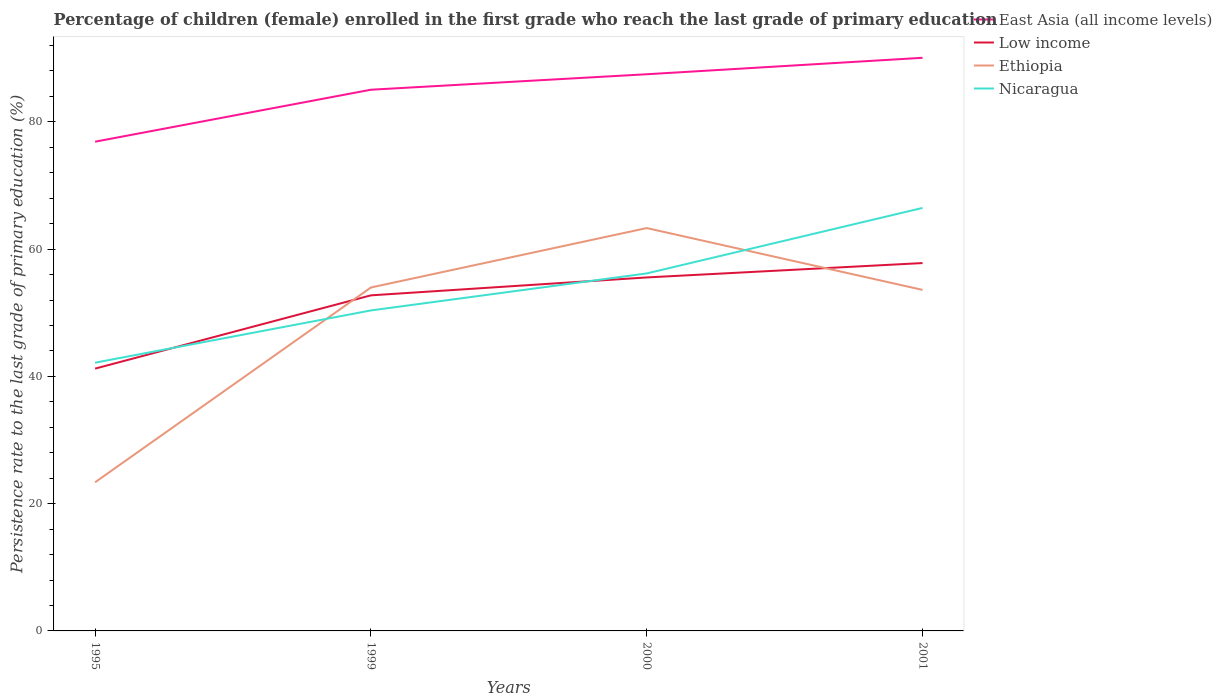How many different coloured lines are there?
Your response must be concise. 4. Is the number of lines equal to the number of legend labels?
Make the answer very short. Yes. Across all years, what is the maximum persistence rate of children in East Asia (all income levels)?
Offer a terse response. 76.89. What is the total persistence rate of children in Nicaragua in the graph?
Make the answer very short. -24.32. What is the difference between the highest and the second highest persistence rate of children in Nicaragua?
Give a very brief answer. 24.32. What is the difference between the highest and the lowest persistence rate of children in Ethiopia?
Make the answer very short. 3. Is the persistence rate of children in Nicaragua strictly greater than the persistence rate of children in East Asia (all income levels) over the years?
Your response must be concise. Yes. Are the values on the major ticks of Y-axis written in scientific E-notation?
Provide a succinct answer. No. Does the graph contain grids?
Your answer should be very brief. No. Where does the legend appear in the graph?
Make the answer very short. Top right. How many legend labels are there?
Provide a succinct answer. 4. How are the legend labels stacked?
Provide a short and direct response. Vertical. What is the title of the graph?
Offer a terse response. Percentage of children (female) enrolled in the first grade who reach the last grade of primary education. What is the label or title of the Y-axis?
Keep it short and to the point. Persistence rate to the last grade of primary education (%). What is the Persistence rate to the last grade of primary education (%) of East Asia (all income levels) in 1995?
Provide a short and direct response. 76.89. What is the Persistence rate to the last grade of primary education (%) in Low income in 1995?
Keep it short and to the point. 41.22. What is the Persistence rate to the last grade of primary education (%) of Ethiopia in 1995?
Offer a very short reply. 23.36. What is the Persistence rate to the last grade of primary education (%) of Nicaragua in 1995?
Offer a terse response. 42.16. What is the Persistence rate to the last grade of primary education (%) in East Asia (all income levels) in 1999?
Your answer should be very brief. 85.05. What is the Persistence rate to the last grade of primary education (%) in Low income in 1999?
Make the answer very short. 52.74. What is the Persistence rate to the last grade of primary education (%) in Ethiopia in 1999?
Ensure brevity in your answer.  53.97. What is the Persistence rate to the last grade of primary education (%) of Nicaragua in 1999?
Ensure brevity in your answer.  50.37. What is the Persistence rate to the last grade of primary education (%) of East Asia (all income levels) in 2000?
Provide a succinct answer. 87.48. What is the Persistence rate to the last grade of primary education (%) of Low income in 2000?
Your answer should be compact. 55.55. What is the Persistence rate to the last grade of primary education (%) of Ethiopia in 2000?
Give a very brief answer. 63.31. What is the Persistence rate to the last grade of primary education (%) in Nicaragua in 2000?
Give a very brief answer. 56.18. What is the Persistence rate to the last grade of primary education (%) of East Asia (all income levels) in 2001?
Provide a short and direct response. 90.07. What is the Persistence rate to the last grade of primary education (%) of Low income in 2001?
Offer a terse response. 57.81. What is the Persistence rate to the last grade of primary education (%) of Ethiopia in 2001?
Offer a terse response. 53.6. What is the Persistence rate to the last grade of primary education (%) in Nicaragua in 2001?
Keep it short and to the point. 66.48. Across all years, what is the maximum Persistence rate to the last grade of primary education (%) in East Asia (all income levels)?
Offer a terse response. 90.07. Across all years, what is the maximum Persistence rate to the last grade of primary education (%) of Low income?
Offer a very short reply. 57.81. Across all years, what is the maximum Persistence rate to the last grade of primary education (%) of Ethiopia?
Your answer should be compact. 63.31. Across all years, what is the maximum Persistence rate to the last grade of primary education (%) in Nicaragua?
Your response must be concise. 66.48. Across all years, what is the minimum Persistence rate to the last grade of primary education (%) in East Asia (all income levels)?
Your answer should be compact. 76.89. Across all years, what is the minimum Persistence rate to the last grade of primary education (%) of Low income?
Offer a very short reply. 41.22. Across all years, what is the minimum Persistence rate to the last grade of primary education (%) in Ethiopia?
Provide a succinct answer. 23.36. Across all years, what is the minimum Persistence rate to the last grade of primary education (%) in Nicaragua?
Give a very brief answer. 42.16. What is the total Persistence rate to the last grade of primary education (%) of East Asia (all income levels) in the graph?
Your answer should be compact. 339.49. What is the total Persistence rate to the last grade of primary education (%) in Low income in the graph?
Provide a short and direct response. 207.33. What is the total Persistence rate to the last grade of primary education (%) of Ethiopia in the graph?
Your answer should be very brief. 194.24. What is the total Persistence rate to the last grade of primary education (%) in Nicaragua in the graph?
Your answer should be compact. 215.18. What is the difference between the Persistence rate to the last grade of primary education (%) in East Asia (all income levels) in 1995 and that in 1999?
Make the answer very short. -8.17. What is the difference between the Persistence rate to the last grade of primary education (%) of Low income in 1995 and that in 1999?
Keep it short and to the point. -11.52. What is the difference between the Persistence rate to the last grade of primary education (%) of Ethiopia in 1995 and that in 1999?
Offer a very short reply. -30.61. What is the difference between the Persistence rate to the last grade of primary education (%) of Nicaragua in 1995 and that in 1999?
Your answer should be compact. -8.21. What is the difference between the Persistence rate to the last grade of primary education (%) of East Asia (all income levels) in 1995 and that in 2000?
Give a very brief answer. -10.6. What is the difference between the Persistence rate to the last grade of primary education (%) in Low income in 1995 and that in 2000?
Provide a short and direct response. -14.33. What is the difference between the Persistence rate to the last grade of primary education (%) of Ethiopia in 1995 and that in 2000?
Ensure brevity in your answer.  -39.95. What is the difference between the Persistence rate to the last grade of primary education (%) in Nicaragua in 1995 and that in 2000?
Your answer should be very brief. -14.03. What is the difference between the Persistence rate to the last grade of primary education (%) in East Asia (all income levels) in 1995 and that in 2001?
Keep it short and to the point. -13.18. What is the difference between the Persistence rate to the last grade of primary education (%) of Low income in 1995 and that in 2001?
Your answer should be compact. -16.59. What is the difference between the Persistence rate to the last grade of primary education (%) in Ethiopia in 1995 and that in 2001?
Give a very brief answer. -30.23. What is the difference between the Persistence rate to the last grade of primary education (%) of Nicaragua in 1995 and that in 2001?
Give a very brief answer. -24.32. What is the difference between the Persistence rate to the last grade of primary education (%) of East Asia (all income levels) in 1999 and that in 2000?
Make the answer very short. -2.43. What is the difference between the Persistence rate to the last grade of primary education (%) in Low income in 1999 and that in 2000?
Provide a succinct answer. -2.81. What is the difference between the Persistence rate to the last grade of primary education (%) of Ethiopia in 1999 and that in 2000?
Provide a short and direct response. -9.34. What is the difference between the Persistence rate to the last grade of primary education (%) of Nicaragua in 1999 and that in 2000?
Make the answer very short. -5.82. What is the difference between the Persistence rate to the last grade of primary education (%) of East Asia (all income levels) in 1999 and that in 2001?
Your answer should be compact. -5.02. What is the difference between the Persistence rate to the last grade of primary education (%) in Low income in 1999 and that in 2001?
Your answer should be compact. -5.07. What is the difference between the Persistence rate to the last grade of primary education (%) in Ethiopia in 1999 and that in 2001?
Your response must be concise. 0.38. What is the difference between the Persistence rate to the last grade of primary education (%) in Nicaragua in 1999 and that in 2001?
Make the answer very short. -16.11. What is the difference between the Persistence rate to the last grade of primary education (%) in East Asia (all income levels) in 2000 and that in 2001?
Provide a short and direct response. -2.59. What is the difference between the Persistence rate to the last grade of primary education (%) of Low income in 2000 and that in 2001?
Your answer should be compact. -2.26. What is the difference between the Persistence rate to the last grade of primary education (%) of Ethiopia in 2000 and that in 2001?
Your answer should be compact. 9.72. What is the difference between the Persistence rate to the last grade of primary education (%) of Nicaragua in 2000 and that in 2001?
Offer a very short reply. -10.29. What is the difference between the Persistence rate to the last grade of primary education (%) of East Asia (all income levels) in 1995 and the Persistence rate to the last grade of primary education (%) of Low income in 1999?
Your answer should be very brief. 24.15. What is the difference between the Persistence rate to the last grade of primary education (%) of East Asia (all income levels) in 1995 and the Persistence rate to the last grade of primary education (%) of Ethiopia in 1999?
Offer a very short reply. 22.91. What is the difference between the Persistence rate to the last grade of primary education (%) of East Asia (all income levels) in 1995 and the Persistence rate to the last grade of primary education (%) of Nicaragua in 1999?
Provide a succinct answer. 26.52. What is the difference between the Persistence rate to the last grade of primary education (%) of Low income in 1995 and the Persistence rate to the last grade of primary education (%) of Ethiopia in 1999?
Give a very brief answer. -12.75. What is the difference between the Persistence rate to the last grade of primary education (%) of Low income in 1995 and the Persistence rate to the last grade of primary education (%) of Nicaragua in 1999?
Give a very brief answer. -9.14. What is the difference between the Persistence rate to the last grade of primary education (%) in Ethiopia in 1995 and the Persistence rate to the last grade of primary education (%) in Nicaragua in 1999?
Offer a very short reply. -27.01. What is the difference between the Persistence rate to the last grade of primary education (%) in East Asia (all income levels) in 1995 and the Persistence rate to the last grade of primary education (%) in Low income in 2000?
Make the answer very short. 21.33. What is the difference between the Persistence rate to the last grade of primary education (%) in East Asia (all income levels) in 1995 and the Persistence rate to the last grade of primary education (%) in Ethiopia in 2000?
Offer a very short reply. 13.57. What is the difference between the Persistence rate to the last grade of primary education (%) of East Asia (all income levels) in 1995 and the Persistence rate to the last grade of primary education (%) of Nicaragua in 2000?
Provide a succinct answer. 20.7. What is the difference between the Persistence rate to the last grade of primary education (%) of Low income in 1995 and the Persistence rate to the last grade of primary education (%) of Ethiopia in 2000?
Offer a very short reply. -22.09. What is the difference between the Persistence rate to the last grade of primary education (%) in Low income in 1995 and the Persistence rate to the last grade of primary education (%) in Nicaragua in 2000?
Offer a very short reply. -14.96. What is the difference between the Persistence rate to the last grade of primary education (%) in Ethiopia in 1995 and the Persistence rate to the last grade of primary education (%) in Nicaragua in 2000?
Your response must be concise. -32.82. What is the difference between the Persistence rate to the last grade of primary education (%) of East Asia (all income levels) in 1995 and the Persistence rate to the last grade of primary education (%) of Low income in 2001?
Provide a short and direct response. 19.07. What is the difference between the Persistence rate to the last grade of primary education (%) of East Asia (all income levels) in 1995 and the Persistence rate to the last grade of primary education (%) of Ethiopia in 2001?
Your answer should be very brief. 23.29. What is the difference between the Persistence rate to the last grade of primary education (%) of East Asia (all income levels) in 1995 and the Persistence rate to the last grade of primary education (%) of Nicaragua in 2001?
Your answer should be very brief. 10.41. What is the difference between the Persistence rate to the last grade of primary education (%) in Low income in 1995 and the Persistence rate to the last grade of primary education (%) in Ethiopia in 2001?
Offer a very short reply. -12.37. What is the difference between the Persistence rate to the last grade of primary education (%) in Low income in 1995 and the Persistence rate to the last grade of primary education (%) in Nicaragua in 2001?
Your response must be concise. -25.25. What is the difference between the Persistence rate to the last grade of primary education (%) in Ethiopia in 1995 and the Persistence rate to the last grade of primary education (%) in Nicaragua in 2001?
Ensure brevity in your answer.  -43.12. What is the difference between the Persistence rate to the last grade of primary education (%) in East Asia (all income levels) in 1999 and the Persistence rate to the last grade of primary education (%) in Low income in 2000?
Your answer should be very brief. 29.5. What is the difference between the Persistence rate to the last grade of primary education (%) of East Asia (all income levels) in 1999 and the Persistence rate to the last grade of primary education (%) of Ethiopia in 2000?
Provide a succinct answer. 21.74. What is the difference between the Persistence rate to the last grade of primary education (%) in East Asia (all income levels) in 1999 and the Persistence rate to the last grade of primary education (%) in Nicaragua in 2000?
Your answer should be very brief. 28.87. What is the difference between the Persistence rate to the last grade of primary education (%) of Low income in 1999 and the Persistence rate to the last grade of primary education (%) of Ethiopia in 2000?
Ensure brevity in your answer.  -10.57. What is the difference between the Persistence rate to the last grade of primary education (%) of Low income in 1999 and the Persistence rate to the last grade of primary education (%) of Nicaragua in 2000?
Make the answer very short. -3.44. What is the difference between the Persistence rate to the last grade of primary education (%) of Ethiopia in 1999 and the Persistence rate to the last grade of primary education (%) of Nicaragua in 2000?
Your answer should be compact. -2.21. What is the difference between the Persistence rate to the last grade of primary education (%) of East Asia (all income levels) in 1999 and the Persistence rate to the last grade of primary education (%) of Low income in 2001?
Offer a very short reply. 27.24. What is the difference between the Persistence rate to the last grade of primary education (%) of East Asia (all income levels) in 1999 and the Persistence rate to the last grade of primary education (%) of Ethiopia in 2001?
Offer a terse response. 31.46. What is the difference between the Persistence rate to the last grade of primary education (%) in East Asia (all income levels) in 1999 and the Persistence rate to the last grade of primary education (%) in Nicaragua in 2001?
Offer a terse response. 18.58. What is the difference between the Persistence rate to the last grade of primary education (%) in Low income in 1999 and the Persistence rate to the last grade of primary education (%) in Ethiopia in 2001?
Provide a short and direct response. -0.86. What is the difference between the Persistence rate to the last grade of primary education (%) in Low income in 1999 and the Persistence rate to the last grade of primary education (%) in Nicaragua in 2001?
Offer a terse response. -13.74. What is the difference between the Persistence rate to the last grade of primary education (%) in Ethiopia in 1999 and the Persistence rate to the last grade of primary education (%) in Nicaragua in 2001?
Offer a very short reply. -12.5. What is the difference between the Persistence rate to the last grade of primary education (%) of East Asia (all income levels) in 2000 and the Persistence rate to the last grade of primary education (%) of Low income in 2001?
Offer a terse response. 29.67. What is the difference between the Persistence rate to the last grade of primary education (%) in East Asia (all income levels) in 2000 and the Persistence rate to the last grade of primary education (%) in Ethiopia in 2001?
Provide a short and direct response. 33.89. What is the difference between the Persistence rate to the last grade of primary education (%) in East Asia (all income levels) in 2000 and the Persistence rate to the last grade of primary education (%) in Nicaragua in 2001?
Your response must be concise. 21.01. What is the difference between the Persistence rate to the last grade of primary education (%) of Low income in 2000 and the Persistence rate to the last grade of primary education (%) of Ethiopia in 2001?
Your answer should be very brief. 1.96. What is the difference between the Persistence rate to the last grade of primary education (%) of Low income in 2000 and the Persistence rate to the last grade of primary education (%) of Nicaragua in 2001?
Offer a very short reply. -10.92. What is the difference between the Persistence rate to the last grade of primary education (%) in Ethiopia in 2000 and the Persistence rate to the last grade of primary education (%) in Nicaragua in 2001?
Provide a succinct answer. -3.17. What is the average Persistence rate to the last grade of primary education (%) of East Asia (all income levels) per year?
Provide a succinct answer. 84.87. What is the average Persistence rate to the last grade of primary education (%) in Low income per year?
Provide a short and direct response. 51.83. What is the average Persistence rate to the last grade of primary education (%) of Ethiopia per year?
Offer a terse response. 48.56. What is the average Persistence rate to the last grade of primary education (%) in Nicaragua per year?
Keep it short and to the point. 53.8. In the year 1995, what is the difference between the Persistence rate to the last grade of primary education (%) in East Asia (all income levels) and Persistence rate to the last grade of primary education (%) in Low income?
Keep it short and to the point. 35.66. In the year 1995, what is the difference between the Persistence rate to the last grade of primary education (%) in East Asia (all income levels) and Persistence rate to the last grade of primary education (%) in Ethiopia?
Provide a short and direct response. 53.53. In the year 1995, what is the difference between the Persistence rate to the last grade of primary education (%) of East Asia (all income levels) and Persistence rate to the last grade of primary education (%) of Nicaragua?
Provide a short and direct response. 34.73. In the year 1995, what is the difference between the Persistence rate to the last grade of primary education (%) of Low income and Persistence rate to the last grade of primary education (%) of Ethiopia?
Offer a terse response. 17.86. In the year 1995, what is the difference between the Persistence rate to the last grade of primary education (%) in Low income and Persistence rate to the last grade of primary education (%) in Nicaragua?
Your response must be concise. -0.93. In the year 1995, what is the difference between the Persistence rate to the last grade of primary education (%) of Ethiopia and Persistence rate to the last grade of primary education (%) of Nicaragua?
Ensure brevity in your answer.  -18.8. In the year 1999, what is the difference between the Persistence rate to the last grade of primary education (%) of East Asia (all income levels) and Persistence rate to the last grade of primary education (%) of Low income?
Provide a succinct answer. 32.31. In the year 1999, what is the difference between the Persistence rate to the last grade of primary education (%) in East Asia (all income levels) and Persistence rate to the last grade of primary education (%) in Ethiopia?
Keep it short and to the point. 31.08. In the year 1999, what is the difference between the Persistence rate to the last grade of primary education (%) of East Asia (all income levels) and Persistence rate to the last grade of primary education (%) of Nicaragua?
Give a very brief answer. 34.69. In the year 1999, what is the difference between the Persistence rate to the last grade of primary education (%) of Low income and Persistence rate to the last grade of primary education (%) of Ethiopia?
Offer a terse response. -1.23. In the year 1999, what is the difference between the Persistence rate to the last grade of primary education (%) in Low income and Persistence rate to the last grade of primary education (%) in Nicaragua?
Your answer should be compact. 2.37. In the year 1999, what is the difference between the Persistence rate to the last grade of primary education (%) of Ethiopia and Persistence rate to the last grade of primary education (%) of Nicaragua?
Make the answer very short. 3.61. In the year 2000, what is the difference between the Persistence rate to the last grade of primary education (%) of East Asia (all income levels) and Persistence rate to the last grade of primary education (%) of Low income?
Make the answer very short. 31.93. In the year 2000, what is the difference between the Persistence rate to the last grade of primary education (%) in East Asia (all income levels) and Persistence rate to the last grade of primary education (%) in Ethiopia?
Provide a short and direct response. 24.17. In the year 2000, what is the difference between the Persistence rate to the last grade of primary education (%) in East Asia (all income levels) and Persistence rate to the last grade of primary education (%) in Nicaragua?
Ensure brevity in your answer.  31.3. In the year 2000, what is the difference between the Persistence rate to the last grade of primary education (%) of Low income and Persistence rate to the last grade of primary education (%) of Ethiopia?
Offer a terse response. -7.76. In the year 2000, what is the difference between the Persistence rate to the last grade of primary education (%) of Low income and Persistence rate to the last grade of primary education (%) of Nicaragua?
Provide a short and direct response. -0.63. In the year 2000, what is the difference between the Persistence rate to the last grade of primary education (%) of Ethiopia and Persistence rate to the last grade of primary education (%) of Nicaragua?
Provide a short and direct response. 7.13. In the year 2001, what is the difference between the Persistence rate to the last grade of primary education (%) of East Asia (all income levels) and Persistence rate to the last grade of primary education (%) of Low income?
Provide a short and direct response. 32.26. In the year 2001, what is the difference between the Persistence rate to the last grade of primary education (%) of East Asia (all income levels) and Persistence rate to the last grade of primary education (%) of Ethiopia?
Your answer should be compact. 36.48. In the year 2001, what is the difference between the Persistence rate to the last grade of primary education (%) in East Asia (all income levels) and Persistence rate to the last grade of primary education (%) in Nicaragua?
Offer a terse response. 23.59. In the year 2001, what is the difference between the Persistence rate to the last grade of primary education (%) of Low income and Persistence rate to the last grade of primary education (%) of Ethiopia?
Keep it short and to the point. 4.22. In the year 2001, what is the difference between the Persistence rate to the last grade of primary education (%) in Low income and Persistence rate to the last grade of primary education (%) in Nicaragua?
Keep it short and to the point. -8.67. In the year 2001, what is the difference between the Persistence rate to the last grade of primary education (%) in Ethiopia and Persistence rate to the last grade of primary education (%) in Nicaragua?
Your response must be concise. -12.88. What is the ratio of the Persistence rate to the last grade of primary education (%) in East Asia (all income levels) in 1995 to that in 1999?
Make the answer very short. 0.9. What is the ratio of the Persistence rate to the last grade of primary education (%) in Low income in 1995 to that in 1999?
Offer a very short reply. 0.78. What is the ratio of the Persistence rate to the last grade of primary education (%) of Ethiopia in 1995 to that in 1999?
Offer a very short reply. 0.43. What is the ratio of the Persistence rate to the last grade of primary education (%) in Nicaragua in 1995 to that in 1999?
Provide a short and direct response. 0.84. What is the ratio of the Persistence rate to the last grade of primary education (%) in East Asia (all income levels) in 1995 to that in 2000?
Provide a short and direct response. 0.88. What is the ratio of the Persistence rate to the last grade of primary education (%) in Low income in 1995 to that in 2000?
Your answer should be very brief. 0.74. What is the ratio of the Persistence rate to the last grade of primary education (%) of Ethiopia in 1995 to that in 2000?
Ensure brevity in your answer.  0.37. What is the ratio of the Persistence rate to the last grade of primary education (%) of Nicaragua in 1995 to that in 2000?
Your response must be concise. 0.75. What is the ratio of the Persistence rate to the last grade of primary education (%) of East Asia (all income levels) in 1995 to that in 2001?
Your answer should be very brief. 0.85. What is the ratio of the Persistence rate to the last grade of primary education (%) in Low income in 1995 to that in 2001?
Ensure brevity in your answer.  0.71. What is the ratio of the Persistence rate to the last grade of primary education (%) in Ethiopia in 1995 to that in 2001?
Your response must be concise. 0.44. What is the ratio of the Persistence rate to the last grade of primary education (%) in Nicaragua in 1995 to that in 2001?
Give a very brief answer. 0.63. What is the ratio of the Persistence rate to the last grade of primary education (%) of East Asia (all income levels) in 1999 to that in 2000?
Your response must be concise. 0.97. What is the ratio of the Persistence rate to the last grade of primary education (%) of Low income in 1999 to that in 2000?
Provide a succinct answer. 0.95. What is the ratio of the Persistence rate to the last grade of primary education (%) in Ethiopia in 1999 to that in 2000?
Your answer should be very brief. 0.85. What is the ratio of the Persistence rate to the last grade of primary education (%) of Nicaragua in 1999 to that in 2000?
Ensure brevity in your answer.  0.9. What is the ratio of the Persistence rate to the last grade of primary education (%) of East Asia (all income levels) in 1999 to that in 2001?
Your answer should be compact. 0.94. What is the ratio of the Persistence rate to the last grade of primary education (%) in Low income in 1999 to that in 2001?
Give a very brief answer. 0.91. What is the ratio of the Persistence rate to the last grade of primary education (%) of Ethiopia in 1999 to that in 2001?
Offer a very short reply. 1.01. What is the ratio of the Persistence rate to the last grade of primary education (%) in Nicaragua in 1999 to that in 2001?
Offer a terse response. 0.76. What is the ratio of the Persistence rate to the last grade of primary education (%) of East Asia (all income levels) in 2000 to that in 2001?
Give a very brief answer. 0.97. What is the ratio of the Persistence rate to the last grade of primary education (%) in Low income in 2000 to that in 2001?
Provide a short and direct response. 0.96. What is the ratio of the Persistence rate to the last grade of primary education (%) of Ethiopia in 2000 to that in 2001?
Offer a terse response. 1.18. What is the ratio of the Persistence rate to the last grade of primary education (%) in Nicaragua in 2000 to that in 2001?
Your answer should be very brief. 0.85. What is the difference between the highest and the second highest Persistence rate to the last grade of primary education (%) of East Asia (all income levels)?
Offer a terse response. 2.59. What is the difference between the highest and the second highest Persistence rate to the last grade of primary education (%) in Low income?
Give a very brief answer. 2.26. What is the difference between the highest and the second highest Persistence rate to the last grade of primary education (%) in Ethiopia?
Your response must be concise. 9.34. What is the difference between the highest and the second highest Persistence rate to the last grade of primary education (%) in Nicaragua?
Ensure brevity in your answer.  10.29. What is the difference between the highest and the lowest Persistence rate to the last grade of primary education (%) of East Asia (all income levels)?
Your response must be concise. 13.18. What is the difference between the highest and the lowest Persistence rate to the last grade of primary education (%) in Low income?
Your answer should be compact. 16.59. What is the difference between the highest and the lowest Persistence rate to the last grade of primary education (%) in Ethiopia?
Provide a short and direct response. 39.95. What is the difference between the highest and the lowest Persistence rate to the last grade of primary education (%) in Nicaragua?
Provide a short and direct response. 24.32. 